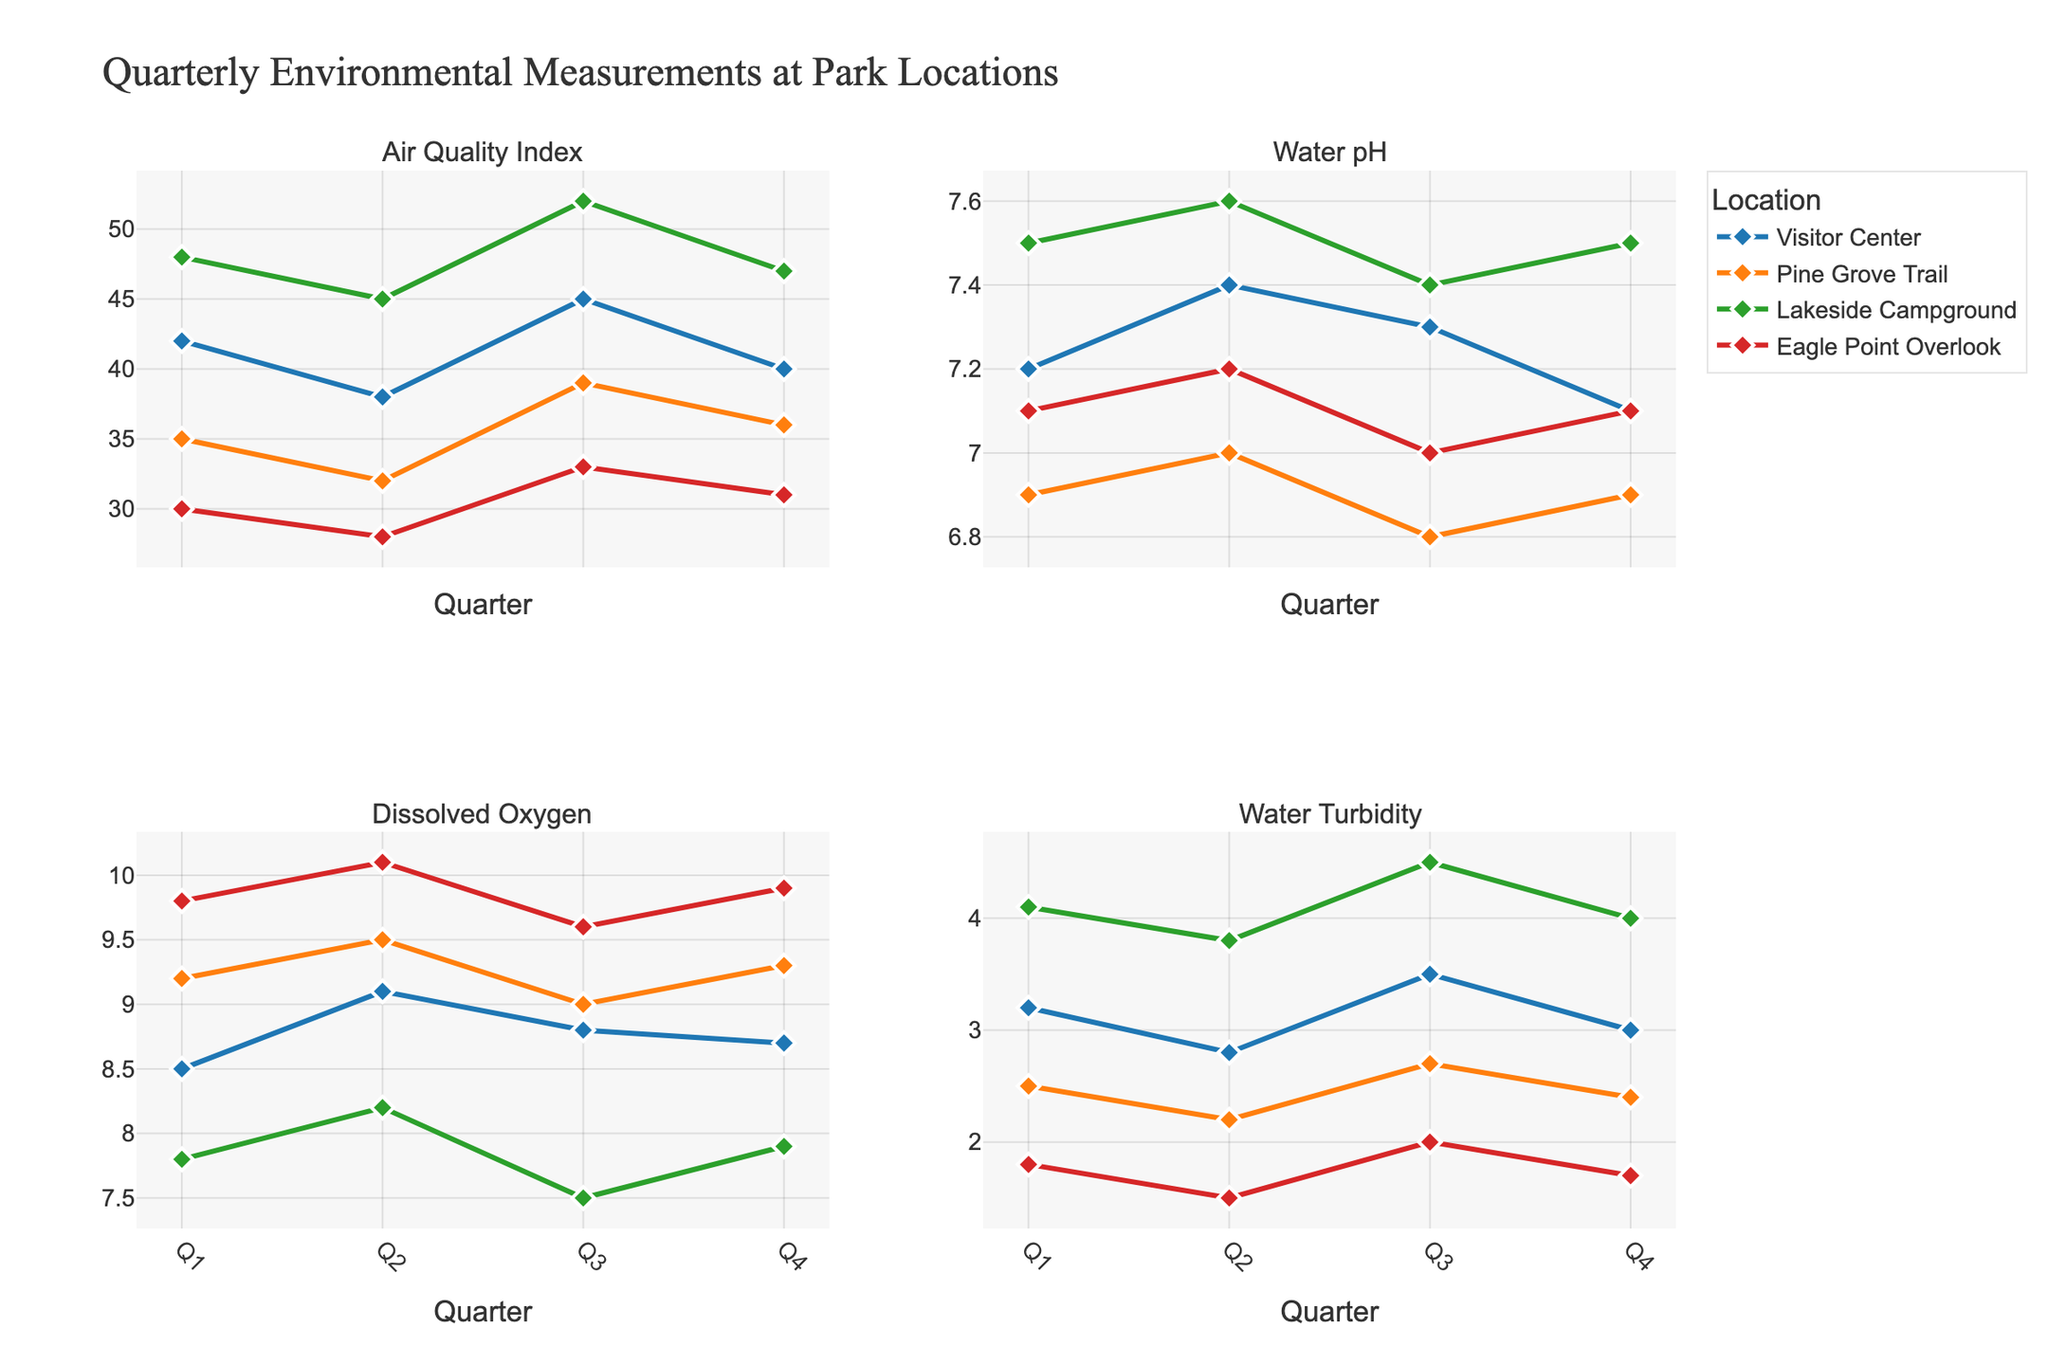what is the title of the figure? The title is prominently displayed at the top of the figure. By looking at the top center of the figure, the title reads "Quarterly Environmental Measurements at Park Locations".
Answer: Quarterly Environmental Measurements at Park Locations Which location has the highest Air Quality Index in Q3? By observing the "Air Quality Index" subplot (first subplot, first row), the line for Lakeside Campground (green) reaches the highest value of 52 in Q3.
Answer: Lakeside Campground What is the general trend of Water pH at Pine Grove Trail over the four quarters? Look at the "Water pH" subplot (first row, second column). The orange line representing Pine Grove Trail shows slight variation but remains around 6.8 to 7.0 throughout the four quarters, indicating relatively stable pH levels.
Answer: Relatively stable How does the Water Dissolved Oxygen level at Eagle Point Overlook in Q2 compare to Q3? Check the "Dissolved Oxygen" subplot (second row, first column), and find the red line for Eagle Point Overlook. The Dissolved Oxygen level increases from 9.8 in Q1 to 10.1 in Q2 and then decreases to 9.6 in Q3.
Answer: It decreases in Q3 What's the difference in Water Turbidity between the Visitor Center and Pine Grove Trail in Q1? In the "Water Turbidity" subplot (second row, second column), find the blue and orange lines for Visitor Center and Pine Grove Trail respectively. The values are 3.2 for Visitor Center and 2.5 for Pine Grove Trail in Q1. The difference is 3.2 - 2.5 = 0.7.
Answer: 0.7 Which location shows the largest variation in Water pH across all quarters? Examine the "Water pH" subplot in the first row, second column. By comparing the variability range, Lakeside Campground (green line) shows a narrow range (7.4 - 7.6), Pine Grove Trail (orange) also shows a narrow range (6.8 - 7.0), but Visitor Center (blue) and Eagle Point Overlook (red) show a range of 7.1 - 7.4 and 7.0 - 7.2 respectively. Pine Grove Trail shows the most noticeable variation from 6.8 to 7.0.
Answer: Pine Grove Trail What is the general trend for Air Quality Index at the Visitor Center throughout the year? Check the "Air Quality Index" subplot (first row, first column). The blue line representing Visitor Center shows a minor fluctuation with values going from 42 in Q1, 38 in Q2, 45 in Q3, and 40 in Q4 – it fluctuates but does not change drastically.
Answer: Fluctuating with minor variations Which location has the lowest Water Dissolved Oxygen in Q1? Look at the "Dissolved Oxygen" subplot (second row, first column) and observe the points in Q1. Eagle Point Overlook has the lowest value at 9.8 (red line).
Answer: Eagle Point Overlook How does the Water Turbidity at Lakeside Campground in Q3 compare to Q4? In the "Water Turbidity" subplot (second row, second column), for Lakeside Campground (green line), the values are 4.5 in Q3 and 4.0 in Q4.
Answer: It decreases Which quarter shows the highest number of highest measurements overall for Water Dissolved Oxygen across all locations? Observe the highest points in each line within the "Dissolved Oxygen" subplot. Q2 shows the highest values: 10.1 for Eagle Point Overlook, 9.5 for Pine Grove Trail, and 9.1 for the Visitor Center.
Answer: Q2 